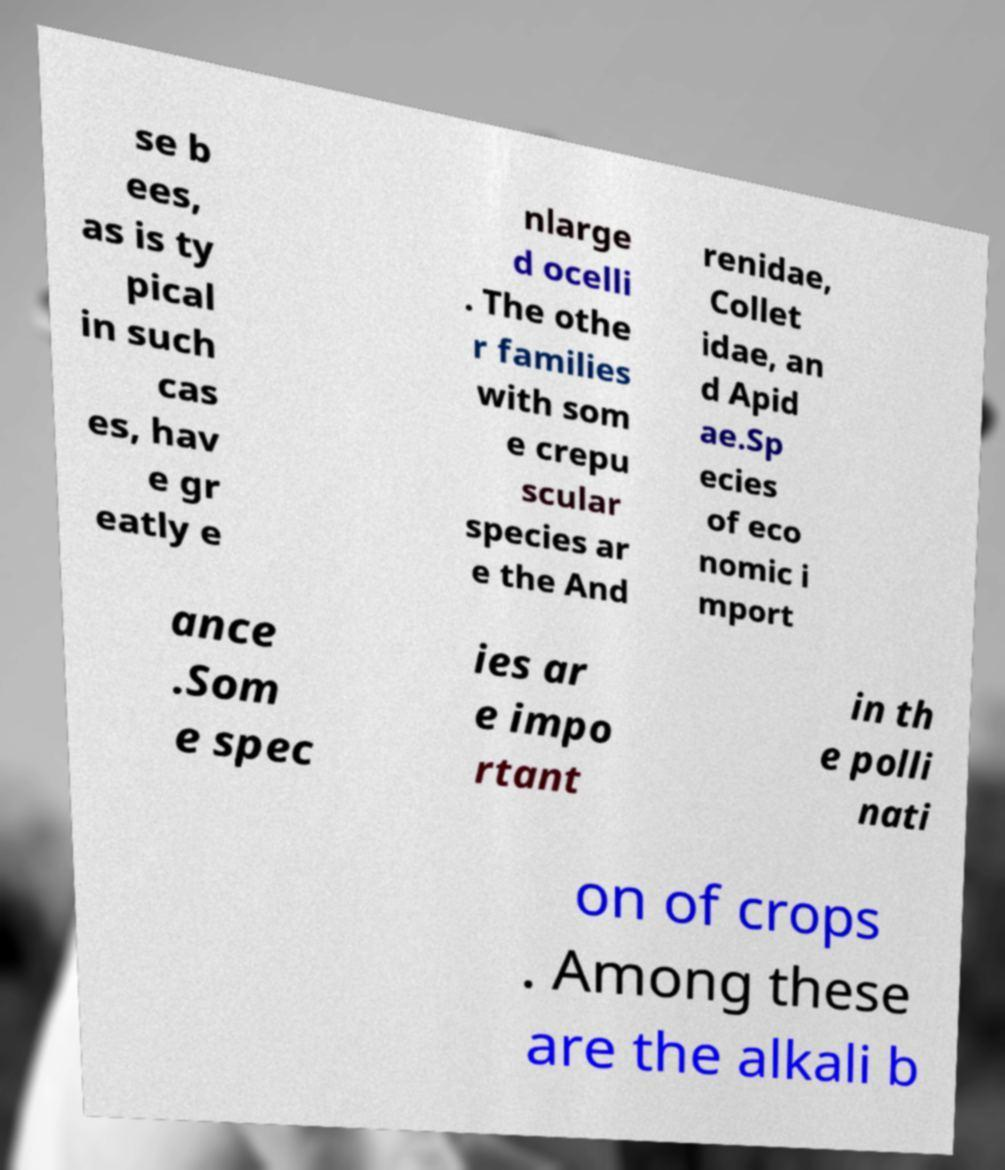What messages or text are displayed in this image? I need them in a readable, typed format. se b ees, as is ty pical in such cas es, hav e gr eatly e nlarge d ocelli . The othe r families with som e crepu scular species ar e the And renidae, Collet idae, an d Apid ae.Sp ecies of eco nomic i mport ance .Som e spec ies ar e impo rtant in th e polli nati on of crops . Among these are the alkali b 